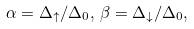<formula> <loc_0><loc_0><loc_500><loc_500>\alpha = \Delta _ { \uparrow } / \Delta _ { 0 } , \, \beta = \Delta _ { \downarrow } / \Delta _ { 0 } ,</formula> 